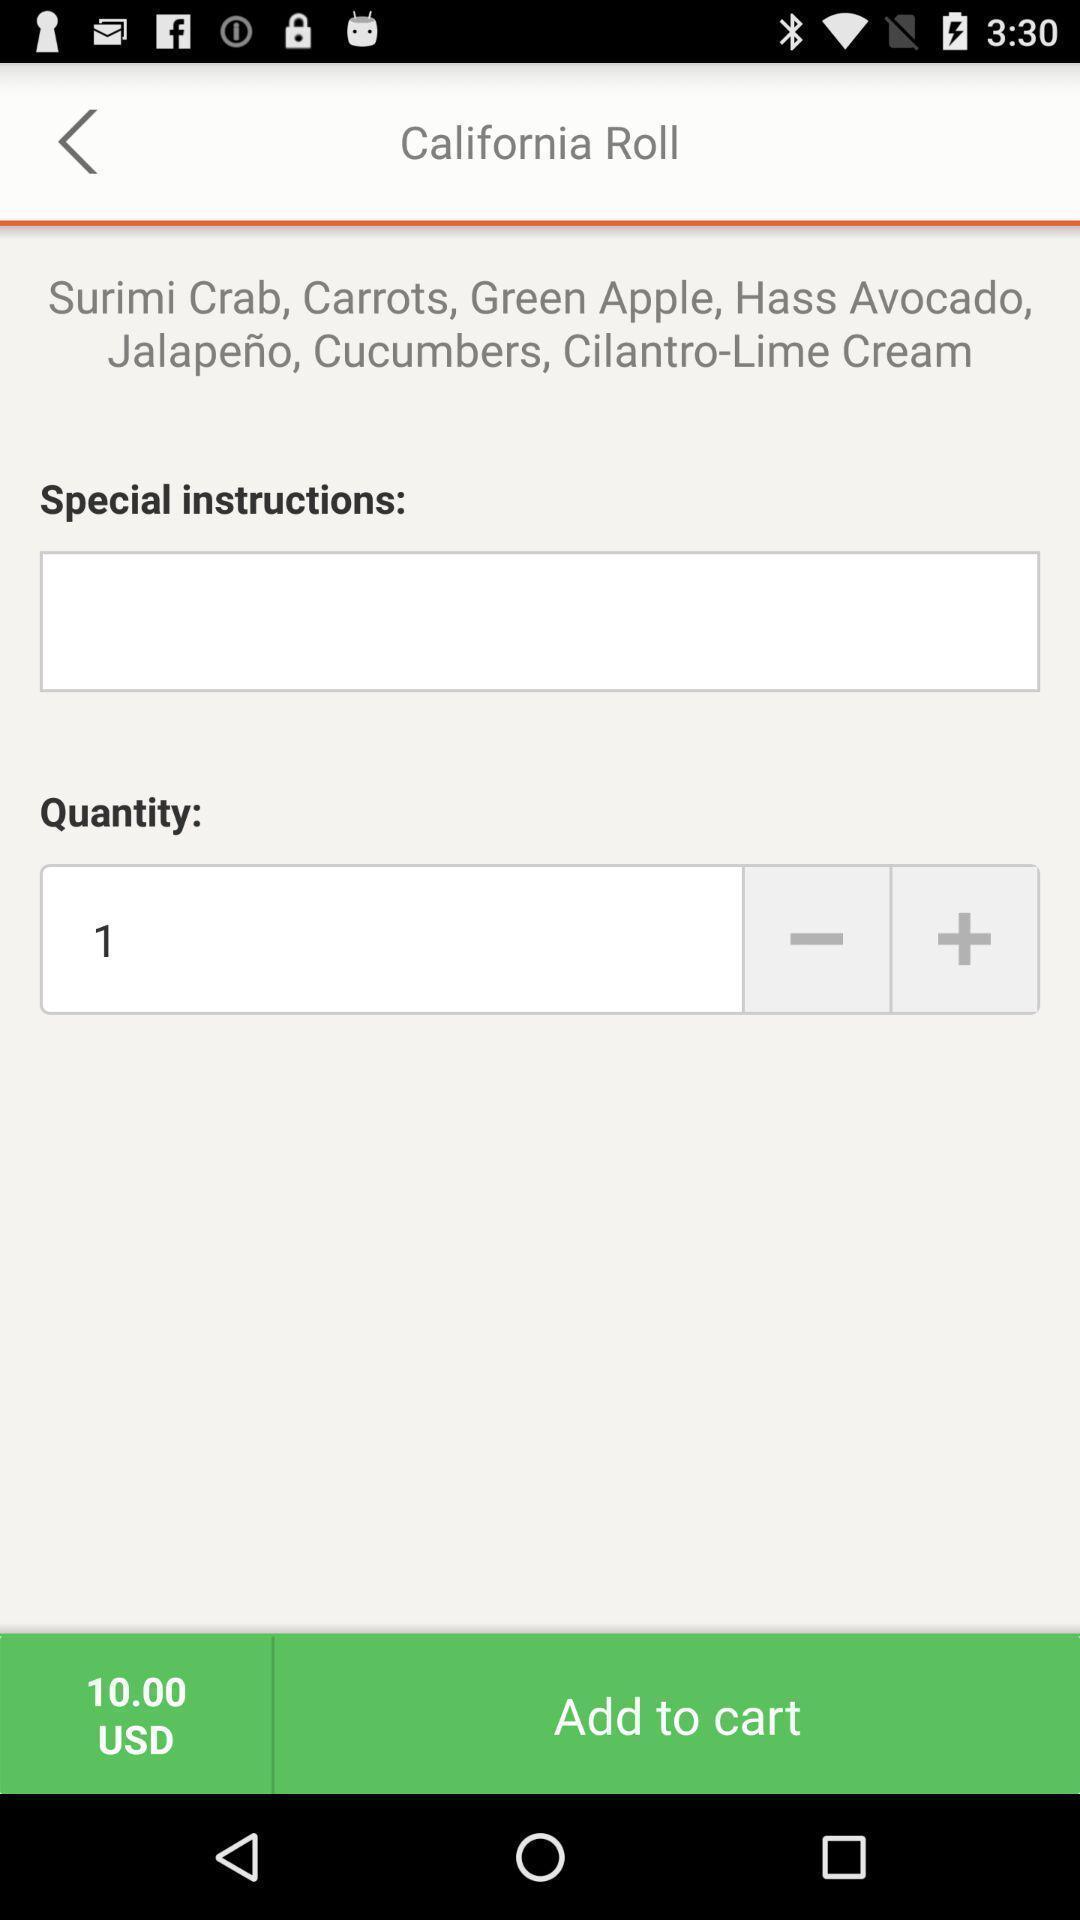Describe the content in this image. Screen page displaying different options in groceries application. 